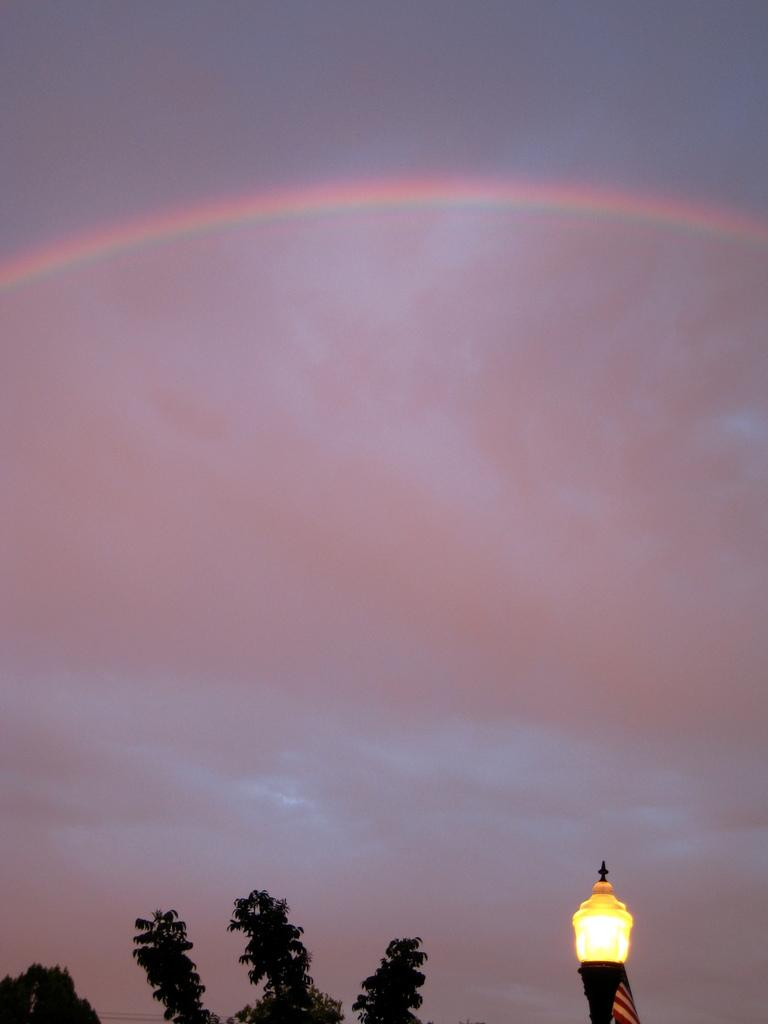What type of natural object can be seen in the image? There is a tree in the image. What man-made object is present in the image? There is a light pole in the image. What atmospheric phenomenon can be seen in the background of the image? There is a rainbow in the background of the image. What else can be seen in the background of the image? There are clouds in the background of the image. What is visible in the far background of the image? The sky is visible in the background of the image. What punishment is being given to the tree in the image? There is no punishment being given to the tree in the image; it is a natural object. How many stars can be seen in the image? There are no stars visible in the image. 